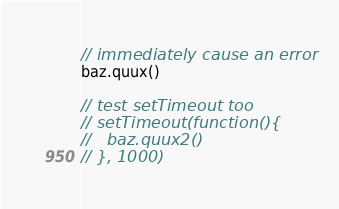<code> <loc_0><loc_0><loc_500><loc_500><_JavaScript_>// immediately cause an error
baz.quux()

// test setTimeout too
// setTimeout(function(){
//   baz.quux2()
// }, 1000)</code> 